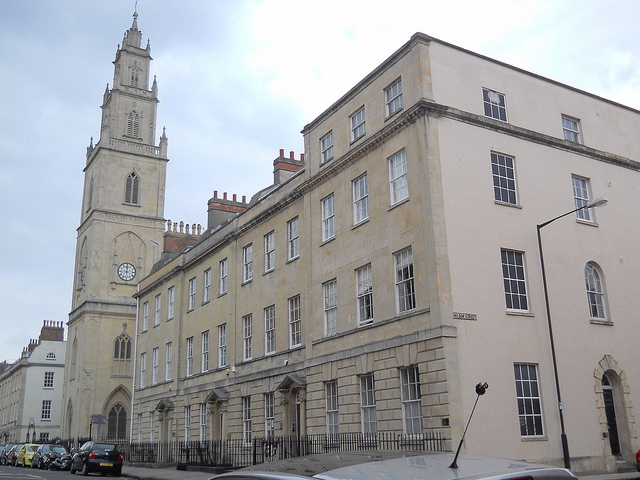Describe a historical scenario involving this building. In the late 18th century, this building served as a prominent meeting place for the city's intellectuals and political leaders. It was here that they debated the burgeoning ideas of democracy and the roles of science and philosophy in society. One notable event was the secret meeting held in 1793, where plans were drafted to establish the first public library in the city. This decision was pivotal, influencing the cultural and educational development of the area.  Briefly describe an event that might have taken place in one of the rooms. One of the rooms likely hosted an elegant dinner party in the 19th century, where city dignitaries gathered to celebrate the completion of a new public park. 